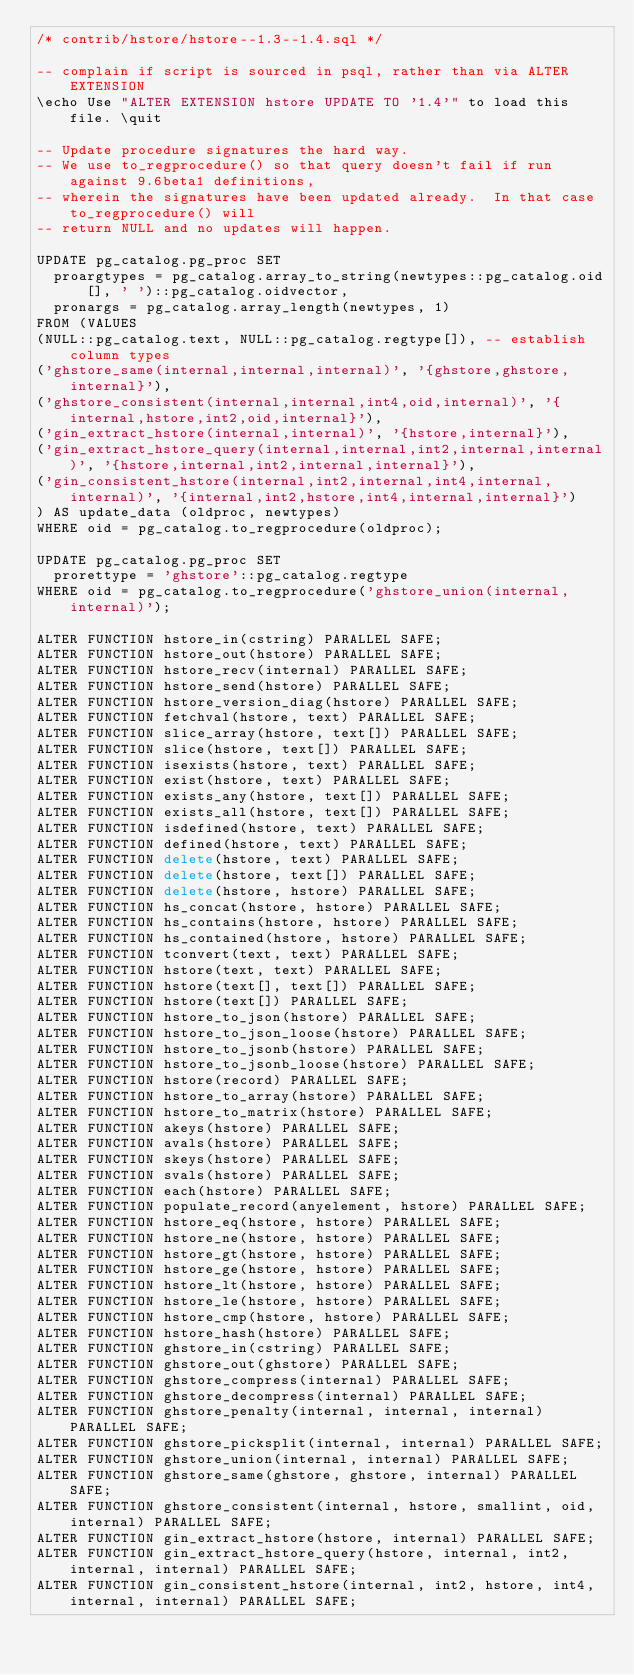Convert code to text. <code><loc_0><loc_0><loc_500><loc_500><_SQL_>/* contrib/hstore/hstore--1.3--1.4.sql */

-- complain if script is sourced in psql, rather than via ALTER EXTENSION
\echo Use "ALTER EXTENSION hstore UPDATE TO '1.4'" to load this file. \quit

-- Update procedure signatures the hard way.
-- We use to_regprocedure() so that query doesn't fail if run against 9.6beta1 definitions,
-- wherein the signatures have been updated already.  In that case to_regprocedure() will
-- return NULL and no updates will happen.

UPDATE pg_catalog.pg_proc SET
  proargtypes = pg_catalog.array_to_string(newtypes::pg_catalog.oid[], ' ')::pg_catalog.oidvector,
  pronargs = pg_catalog.array_length(newtypes, 1)
FROM (VALUES
(NULL::pg_catalog.text, NULL::pg_catalog.regtype[]), -- establish column types
('ghstore_same(internal,internal,internal)', '{ghstore,ghstore,internal}'),
('ghstore_consistent(internal,internal,int4,oid,internal)', '{internal,hstore,int2,oid,internal}'),
('gin_extract_hstore(internal,internal)', '{hstore,internal}'),
('gin_extract_hstore_query(internal,internal,int2,internal,internal)', '{hstore,internal,int2,internal,internal}'),
('gin_consistent_hstore(internal,int2,internal,int4,internal,internal)', '{internal,int2,hstore,int4,internal,internal}')
) AS update_data (oldproc, newtypes)
WHERE oid = pg_catalog.to_regprocedure(oldproc);

UPDATE pg_catalog.pg_proc SET
  prorettype = 'ghstore'::pg_catalog.regtype
WHERE oid = pg_catalog.to_regprocedure('ghstore_union(internal,internal)');

ALTER FUNCTION hstore_in(cstring) PARALLEL SAFE;
ALTER FUNCTION hstore_out(hstore) PARALLEL SAFE;
ALTER FUNCTION hstore_recv(internal) PARALLEL SAFE;
ALTER FUNCTION hstore_send(hstore) PARALLEL SAFE;
ALTER FUNCTION hstore_version_diag(hstore) PARALLEL SAFE;
ALTER FUNCTION fetchval(hstore, text) PARALLEL SAFE;
ALTER FUNCTION slice_array(hstore, text[]) PARALLEL SAFE;
ALTER FUNCTION slice(hstore, text[]) PARALLEL SAFE;
ALTER FUNCTION isexists(hstore, text) PARALLEL SAFE;
ALTER FUNCTION exist(hstore, text) PARALLEL SAFE;
ALTER FUNCTION exists_any(hstore, text[]) PARALLEL SAFE;
ALTER FUNCTION exists_all(hstore, text[]) PARALLEL SAFE;
ALTER FUNCTION isdefined(hstore, text) PARALLEL SAFE;
ALTER FUNCTION defined(hstore, text) PARALLEL SAFE;
ALTER FUNCTION delete(hstore, text) PARALLEL SAFE;
ALTER FUNCTION delete(hstore, text[]) PARALLEL SAFE;
ALTER FUNCTION delete(hstore, hstore) PARALLEL SAFE;
ALTER FUNCTION hs_concat(hstore, hstore) PARALLEL SAFE;
ALTER FUNCTION hs_contains(hstore, hstore) PARALLEL SAFE;
ALTER FUNCTION hs_contained(hstore, hstore) PARALLEL SAFE;
ALTER FUNCTION tconvert(text, text) PARALLEL SAFE;
ALTER FUNCTION hstore(text, text) PARALLEL SAFE;
ALTER FUNCTION hstore(text[], text[]) PARALLEL SAFE;
ALTER FUNCTION hstore(text[]) PARALLEL SAFE;
ALTER FUNCTION hstore_to_json(hstore) PARALLEL SAFE;
ALTER FUNCTION hstore_to_json_loose(hstore) PARALLEL SAFE;
ALTER FUNCTION hstore_to_jsonb(hstore) PARALLEL SAFE;
ALTER FUNCTION hstore_to_jsonb_loose(hstore) PARALLEL SAFE;
ALTER FUNCTION hstore(record) PARALLEL SAFE;
ALTER FUNCTION hstore_to_array(hstore) PARALLEL SAFE;
ALTER FUNCTION hstore_to_matrix(hstore) PARALLEL SAFE;
ALTER FUNCTION akeys(hstore) PARALLEL SAFE;
ALTER FUNCTION avals(hstore) PARALLEL SAFE;
ALTER FUNCTION skeys(hstore) PARALLEL SAFE;
ALTER FUNCTION svals(hstore) PARALLEL SAFE;
ALTER FUNCTION each(hstore) PARALLEL SAFE;
ALTER FUNCTION populate_record(anyelement, hstore) PARALLEL SAFE;
ALTER FUNCTION hstore_eq(hstore, hstore) PARALLEL SAFE;
ALTER FUNCTION hstore_ne(hstore, hstore) PARALLEL SAFE;
ALTER FUNCTION hstore_gt(hstore, hstore) PARALLEL SAFE;
ALTER FUNCTION hstore_ge(hstore, hstore) PARALLEL SAFE;
ALTER FUNCTION hstore_lt(hstore, hstore) PARALLEL SAFE;
ALTER FUNCTION hstore_le(hstore, hstore) PARALLEL SAFE;
ALTER FUNCTION hstore_cmp(hstore, hstore) PARALLEL SAFE;
ALTER FUNCTION hstore_hash(hstore) PARALLEL SAFE;
ALTER FUNCTION ghstore_in(cstring) PARALLEL SAFE;
ALTER FUNCTION ghstore_out(ghstore) PARALLEL SAFE;
ALTER FUNCTION ghstore_compress(internal) PARALLEL SAFE;
ALTER FUNCTION ghstore_decompress(internal) PARALLEL SAFE;
ALTER FUNCTION ghstore_penalty(internal, internal, internal) PARALLEL SAFE;
ALTER FUNCTION ghstore_picksplit(internal, internal) PARALLEL SAFE;
ALTER FUNCTION ghstore_union(internal, internal) PARALLEL SAFE;
ALTER FUNCTION ghstore_same(ghstore, ghstore, internal) PARALLEL SAFE;
ALTER FUNCTION ghstore_consistent(internal, hstore, smallint, oid, internal) PARALLEL SAFE;
ALTER FUNCTION gin_extract_hstore(hstore, internal) PARALLEL SAFE;
ALTER FUNCTION gin_extract_hstore_query(hstore, internal, int2, internal, internal) PARALLEL SAFE;
ALTER FUNCTION gin_consistent_hstore(internal, int2, hstore, int4, internal, internal) PARALLEL SAFE;
</code> 